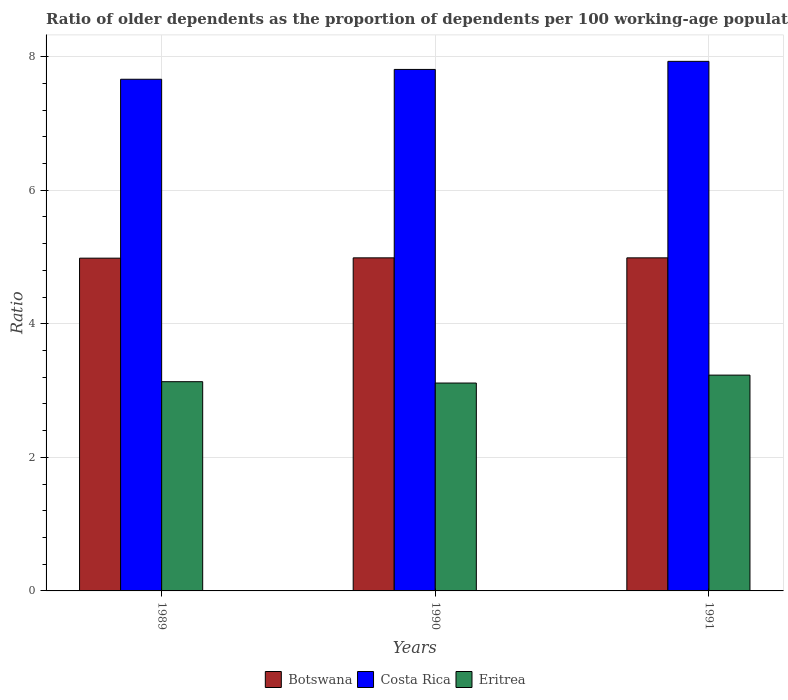How many different coloured bars are there?
Provide a succinct answer. 3. Are the number of bars on each tick of the X-axis equal?
Ensure brevity in your answer.  Yes. How many bars are there on the 2nd tick from the left?
Your response must be concise. 3. How many bars are there on the 3rd tick from the right?
Give a very brief answer. 3. What is the label of the 2nd group of bars from the left?
Your answer should be very brief. 1990. What is the age dependency ratio(old) in Eritrea in 1990?
Make the answer very short. 3.11. Across all years, what is the maximum age dependency ratio(old) in Eritrea?
Offer a terse response. 3.23. Across all years, what is the minimum age dependency ratio(old) in Eritrea?
Your answer should be very brief. 3.11. In which year was the age dependency ratio(old) in Botswana maximum?
Offer a terse response. 1990. What is the total age dependency ratio(old) in Costa Rica in the graph?
Give a very brief answer. 23.4. What is the difference between the age dependency ratio(old) in Eritrea in 1990 and that in 1991?
Provide a succinct answer. -0.12. What is the difference between the age dependency ratio(old) in Eritrea in 1989 and the age dependency ratio(old) in Costa Rica in 1990?
Provide a succinct answer. -4.68. What is the average age dependency ratio(old) in Botswana per year?
Your answer should be compact. 4.99. In the year 1990, what is the difference between the age dependency ratio(old) in Costa Rica and age dependency ratio(old) in Botswana?
Make the answer very short. 2.82. What is the ratio of the age dependency ratio(old) in Costa Rica in 1989 to that in 1991?
Give a very brief answer. 0.97. Is the age dependency ratio(old) in Botswana in 1990 less than that in 1991?
Provide a succinct answer. No. What is the difference between the highest and the second highest age dependency ratio(old) in Eritrea?
Offer a terse response. 0.1. What is the difference between the highest and the lowest age dependency ratio(old) in Costa Rica?
Offer a very short reply. 0.27. Is the sum of the age dependency ratio(old) in Botswana in 1990 and 1991 greater than the maximum age dependency ratio(old) in Eritrea across all years?
Your answer should be compact. Yes. What does the 3rd bar from the left in 1991 represents?
Keep it short and to the point. Eritrea. What does the 3rd bar from the right in 1990 represents?
Keep it short and to the point. Botswana. Are all the bars in the graph horizontal?
Make the answer very short. No. How many years are there in the graph?
Keep it short and to the point. 3. What is the difference between two consecutive major ticks on the Y-axis?
Offer a terse response. 2. Does the graph contain any zero values?
Keep it short and to the point. No. Where does the legend appear in the graph?
Provide a succinct answer. Bottom center. How many legend labels are there?
Keep it short and to the point. 3. What is the title of the graph?
Ensure brevity in your answer.  Ratio of older dependents as the proportion of dependents per 100 working-age population. Does "Sri Lanka" appear as one of the legend labels in the graph?
Keep it short and to the point. No. What is the label or title of the Y-axis?
Offer a very short reply. Ratio. What is the Ratio of Botswana in 1989?
Your response must be concise. 4.98. What is the Ratio of Costa Rica in 1989?
Keep it short and to the point. 7.66. What is the Ratio in Eritrea in 1989?
Give a very brief answer. 3.13. What is the Ratio of Botswana in 1990?
Your answer should be compact. 4.99. What is the Ratio of Costa Rica in 1990?
Give a very brief answer. 7.81. What is the Ratio in Eritrea in 1990?
Provide a short and direct response. 3.11. What is the Ratio in Botswana in 1991?
Keep it short and to the point. 4.99. What is the Ratio in Costa Rica in 1991?
Your answer should be very brief. 7.93. What is the Ratio of Eritrea in 1991?
Provide a short and direct response. 3.23. Across all years, what is the maximum Ratio in Botswana?
Ensure brevity in your answer.  4.99. Across all years, what is the maximum Ratio of Costa Rica?
Ensure brevity in your answer.  7.93. Across all years, what is the maximum Ratio in Eritrea?
Give a very brief answer. 3.23. Across all years, what is the minimum Ratio in Botswana?
Offer a very short reply. 4.98. Across all years, what is the minimum Ratio in Costa Rica?
Provide a succinct answer. 7.66. Across all years, what is the minimum Ratio in Eritrea?
Offer a terse response. 3.11. What is the total Ratio in Botswana in the graph?
Provide a short and direct response. 14.96. What is the total Ratio of Costa Rica in the graph?
Make the answer very short. 23.4. What is the total Ratio of Eritrea in the graph?
Offer a very short reply. 9.48. What is the difference between the Ratio of Botswana in 1989 and that in 1990?
Provide a short and direct response. -0. What is the difference between the Ratio of Costa Rica in 1989 and that in 1990?
Ensure brevity in your answer.  -0.15. What is the difference between the Ratio in Eritrea in 1989 and that in 1990?
Your response must be concise. 0.02. What is the difference between the Ratio of Botswana in 1989 and that in 1991?
Provide a succinct answer. -0. What is the difference between the Ratio of Costa Rica in 1989 and that in 1991?
Offer a very short reply. -0.27. What is the difference between the Ratio of Eritrea in 1989 and that in 1991?
Make the answer very short. -0.1. What is the difference between the Ratio in Costa Rica in 1990 and that in 1991?
Give a very brief answer. -0.12. What is the difference between the Ratio in Eritrea in 1990 and that in 1991?
Keep it short and to the point. -0.12. What is the difference between the Ratio in Botswana in 1989 and the Ratio in Costa Rica in 1990?
Provide a succinct answer. -2.83. What is the difference between the Ratio of Botswana in 1989 and the Ratio of Eritrea in 1990?
Your answer should be very brief. 1.87. What is the difference between the Ratio of Costa Rica in 1989 and the Ratio of Eritrea in 1990?
Provide a succinct answer. 4.55. What is the difference between the Ratio in Botswana in 1989 and the Ratio in Costa Rica in 1991?
Offer a very short reply. -2.95. What is the difference between the Ratio in Botswana in 1989 and the Ratio in Eritrea in 1991?
Make the answer very short. 1.75. What is the difference between the Ratio of Costa Rica in 1989 and the Ratio of Eritrea in 1991?
Give a very brief answer. 4.43. What is the difference between the Ratio of Botswana in 1990 and the Ratio of Costa Rica in 1991?
Your answer should be compact. -2.94. What is the difference between the Ratio of Botswana in 1990 and the Ratio of Eritrea in 1991?
Offer a terse response. 1.76. What is the difference between the Ratio in Costa Rica in 1990 and the Ratio in Eritrea in 1991?
Your answer should be very brief. 4.58. What is the average Ratio in Botswana per year?
Provide a succinct answer. 4.99. What is the average Ratio of Costa Rica per year?
Offer a terse response. 7.8. What is the average Ratio in Eritrea per year?
Offer a terse response. 3.16. In the year 1989, what is the difference between the Ratio in Botswana and Ratio in Costa Rica?
Your answer should be very brief. -2.68. In the year 1989, what is the difference between the Ratio of Botswana and Ratio of Eritrea?
Your response must be concise. 1.85. In the year 1989, what is the difference between the Ratio in Costa Rica and Ratio in Eritrea?
Give a very brief answer. 4.53. In the year 1990, what is the difference between the Ratio of Botswana and Ratio of Costa Rica?
Offer a very short reply. -2.82. In the year 1990, what is the difference between the Ratio of Botswana and Ratio of Eritrea?
Ensure brevity in your answer.  1.87. In the year 1990, what is the difference between the Ratio of Costa Rica and Ratio of Eritrea?
Your answer should be compact. 4.7. In the year 1991, what is the difference between the Ratio in Botswana and Ratio in Costa Rica?
Keep it short and to the point. -2.94. In the year 1991, what is the difference between the Ratio in Botswana and Ratio in Eritrea?
Your answer should be compact. 1.76. In the year 1991, what is the difference between the Ratio in Costa Rica and Ratio in Eritrea?
Your answer should be compact. 4.7. What is the ratio of the Ratio of Costa Rica in 1989 to that in 1990?
Keep it short and to the point. 0.98. What is the ratio of the Ratio in Eritrea in 1989 to that in 1990?
Your answer should be compact. 1.01. What is the ratio of the Ratio of Botswana in 1989 to that in 1991?
Ensure brevity in your answer.  1. What is the ratio of the Ratio of Costa Rica in 1989 to that in 1991?
Offer a terse response. 0.97. What is the ratio of the Ratio of Eritrea in 1989 to that in 1991?
Your answer should be compact. 0.97. What is the ratio of the Ratio of Botswana in 1990 to that in 1991?
Offer a terse response. 1. What is the ratio of the Ratio of Costa Rica in 1990 to that in 1991?
Your answer should be very brief. 0.98. What is the ratio of the Ratio in Eritrea in 1990 to that in 1991?
Ensure brevity in your answer.  0.96. What is the difference between the highest and the second highest Ratio of Botswana?
Keep it short and to the point. 0. What is the difference between the highest and the second highest Ratio in Costa Rica?
Give a very brief answer. 0.12. What is the difference between the highest and the second highest Ratio in Eritrea?
Ensure brevity in your answer.  0.1. What is the difference between the highest and the lowest Ratio of Botswana?
Keep it short and to the point. 0. What is the difference between the highest and the lowest Ratio in Costa Rica?
Give a very brief answer. 0.27. What is the difference between the highest and the lowest Ratio of Eritrea?
Ensure brevity in your answer.  0.12. 